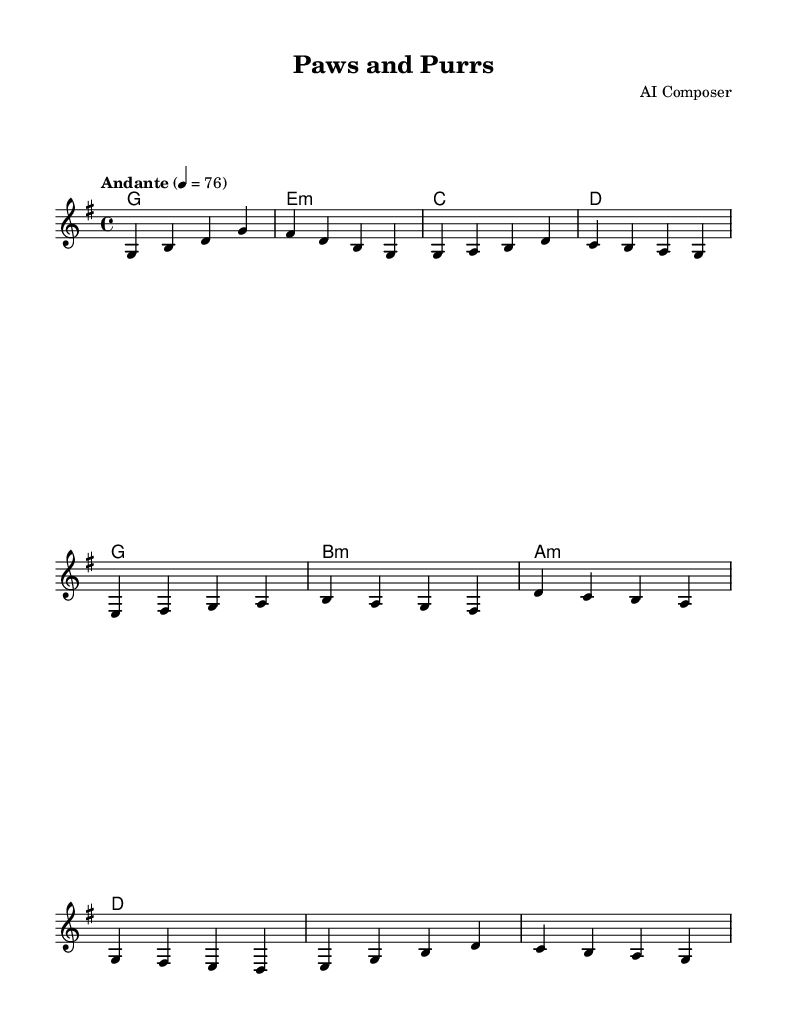what is the key signature of this music? The key signature is indicated at the beginning of the staff and shows two sharps, which means the music is in the key of D major.
Answer: D major what is the time signature of this music? The time signature is placed at the beginning of the piece, showing a "4/4" which means there are 4 beats in each measure and the quarter note gets one beat.
Answer: 4/4 what is the tempo marking for this piece? The tempo marking is found near the top of the music, stating "Andante", which indicates a moderately slow pace.
Answer: Andante how many measures are in section A of the melody? By counting the individual groupings of notes in section A, we see it consists of 4 measures indicated by the vertical lines separating them.
Answer: 4 which chord follows the first melody note in the first measure? The first melody note is "G" and when looking at the chord names directly below, the corresponding chord listed is "G".
Answer: G what is the chord progression in the chorus (section B)? Analyzing the harmonies under the melody in section B, the chords played are D, C, B, A, G, F#, E, D, which forms a recognizable progression in the music.
Answer: D, C, B, A, G, F#, E, D which note serves as the highest pitch in the melody? Observing the melody, the highest pitch is "D", which is found in the first measure of section B, making it the peak of the melody line.
Answer: D 